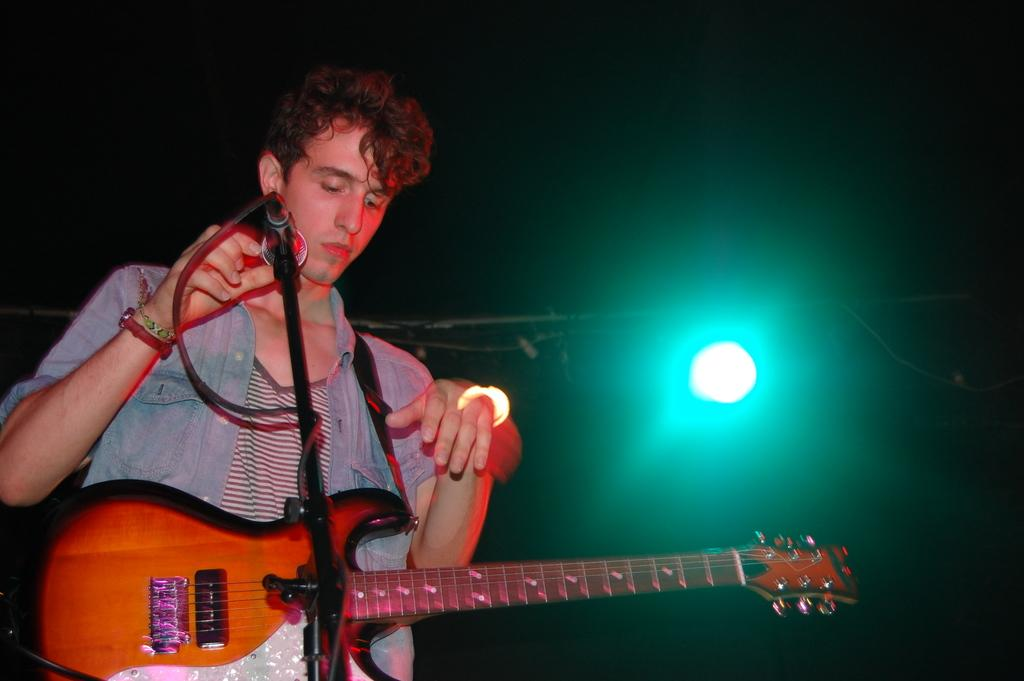What is the man in the image holding? The man is holding a guitar. What is in front of the man? There is a microphone with a stand in front of the man. Is there any equipment associated with the microphone? Yes, there is a cable associated with the microphone. What can be observed about the background of the image? The background of the image is dark, and there is a light visible in the background. What type of toothbrush is the man using in the image? There is no toothbrush present in the image. Can you tell me how many brothers the man has in the image? There is no information about the man's brothers in the image. 